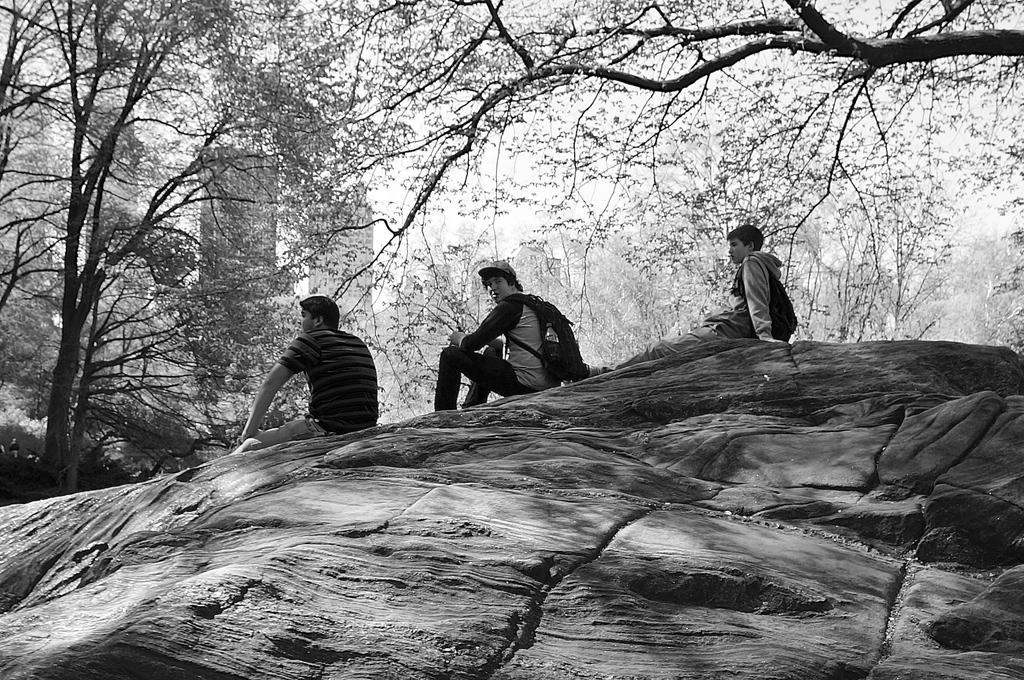In one or two sentences, can you explain what this image depicts? In this image we can see a black and white picture of three persons sitting on a rock. One person wearing a cap and bag. In the background, we can see a group of trees, building and the sky. 